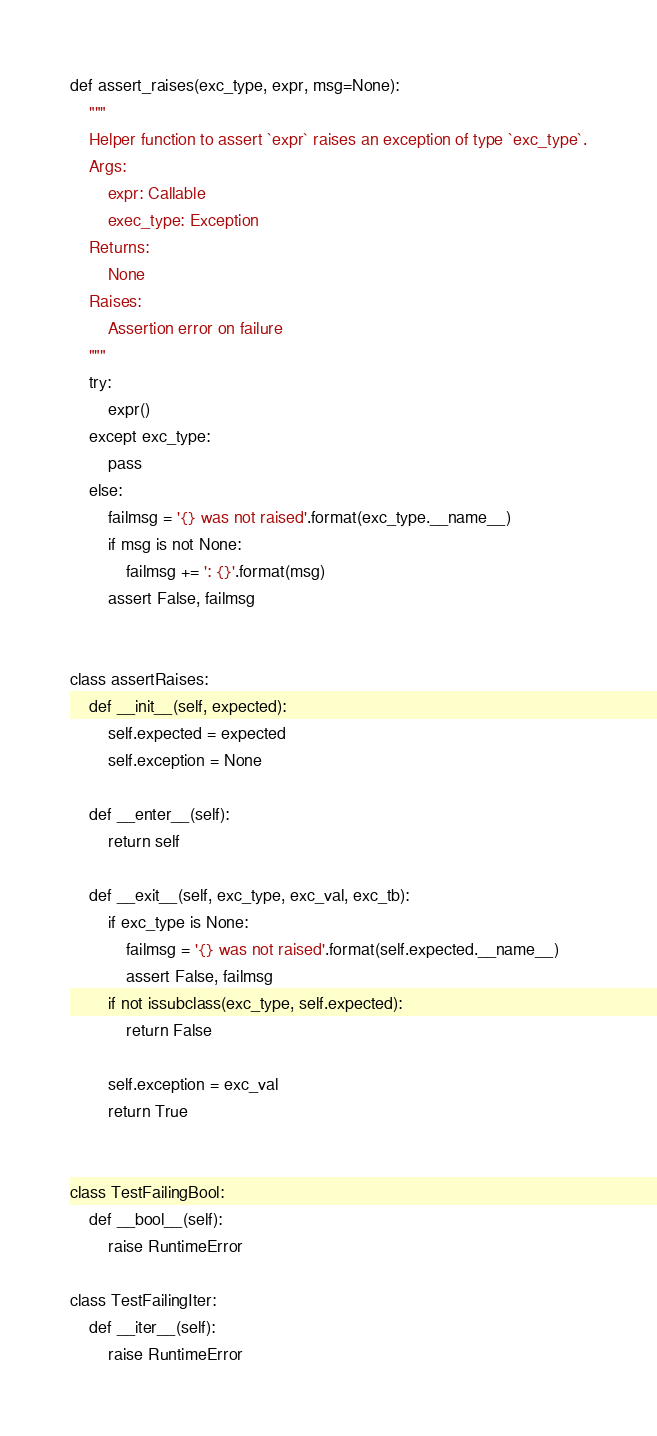<code> <loc_0><loc_0><loc_500><loc_500><_Python_>def assert_raises(exc_type, expr, msg=None):
    """
    Helper function to assert `expr` raises an exception of type `exc_type`.
    Args:
        expr: Callable
        exec_type: Exception
    Returns:
        None
    Raises:
        Assertion error on failure
    """
    try:
        expr()
    except exc_type:
        pass
    else:
        failmsg = '{} was not raised'.format(exc_type.__name__)
        if msg is not None:
            failmsg += ': {}'.format(msg)
        assert False, failmsg


class assertRaises:
    def __init__(self, expected):
        self.expected = expected
        self.exception = None

    def __enter__(self):
        return self

    def __exit__(self, exc_type, exc_val, exc_tb):
        if exc_type is None:
            failmsg = '{} was not raised'.format(self.expected.__name__)
            assert False, failmsg
        if not issubclass(exc_type, self.expected):
            return False

        self.exception = exc_val
        return True


class TestFailingBool:
    def __bool__(self):
        raise RuntimeError

class TestFailingIter:
    def __iter__(self):
        raise RuntimeError
</code> 